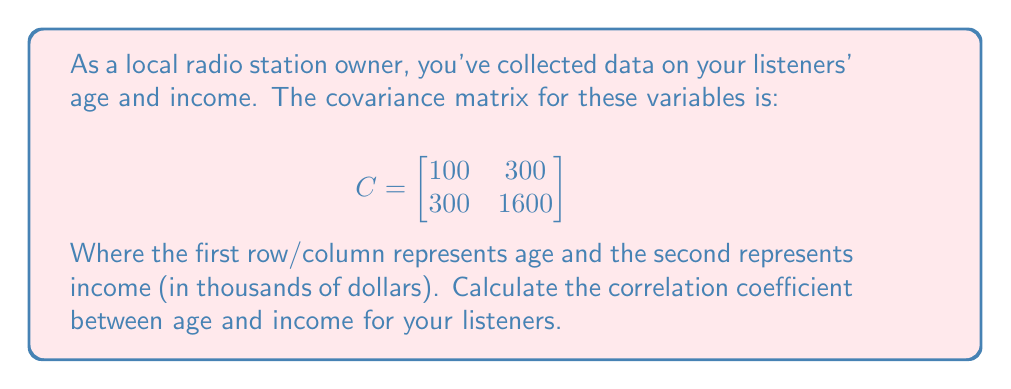Give your solution to this math problem. To calculate the correlation coefficient between age and income, we'll follow these steps:

1. Recall the formula for correlation coefficient:
   $$r = \frac{Cov(X,Y)}{\sqrt{Var(X) \cdot Var(Y)}}$$

2. From the covariance matrix, we can identify:
   - $Var(Age) = C_{11} = 100$
   - $Var(Income) = C_{22} = 1600$
   - $Cov(Age, Income) = C_{12} = C_{21} = 300$

3. Substitute these values into the correlation coefficient formula:
   $$r = \frac{300}{\sqrt{100 \cdot 1600}}$$

4. Simplify:
   $$r = \frac{300}{\sqrt{160000}} = \frac{300}{400} = 0.75$$

Therefore, the correlation coefficient between age and income for your listeners is 0.75.
Answer: 0.75 